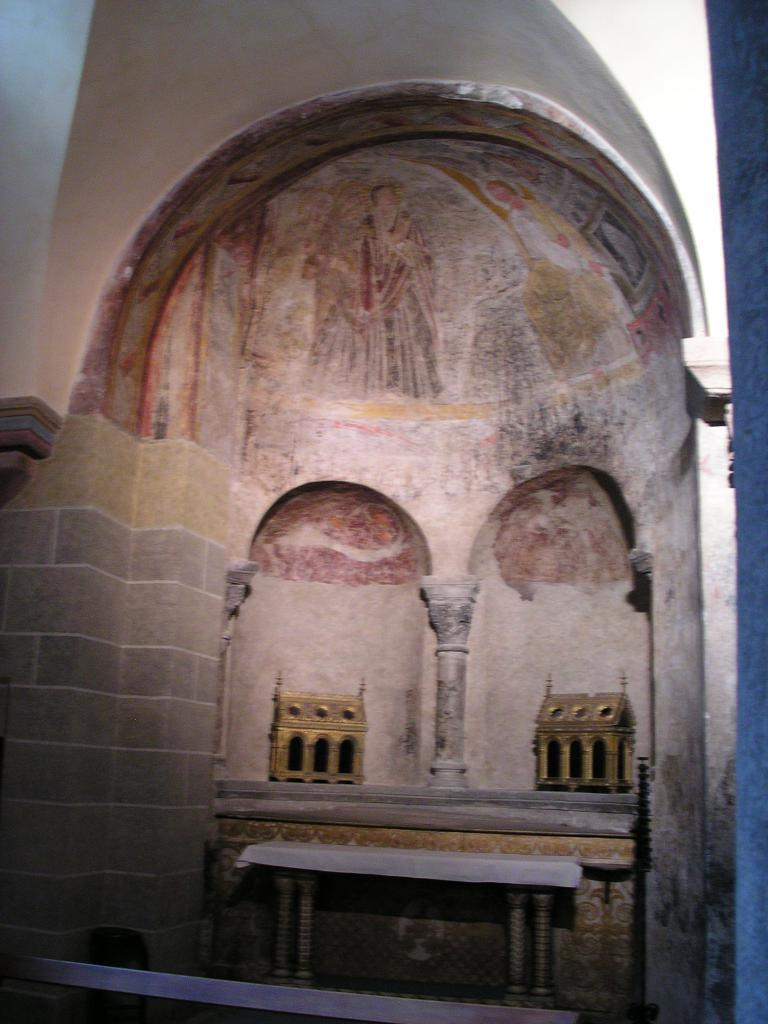What piece of furniture is present in the image? There is a table in the image. What can be seen on or near the table? There are objects on a platform behind the table. What type of artwork is visible in the image? There is a painting on the wall in the background of the image. What type of pot is being used to show the field in the image? There is no pot or field present in the image. 